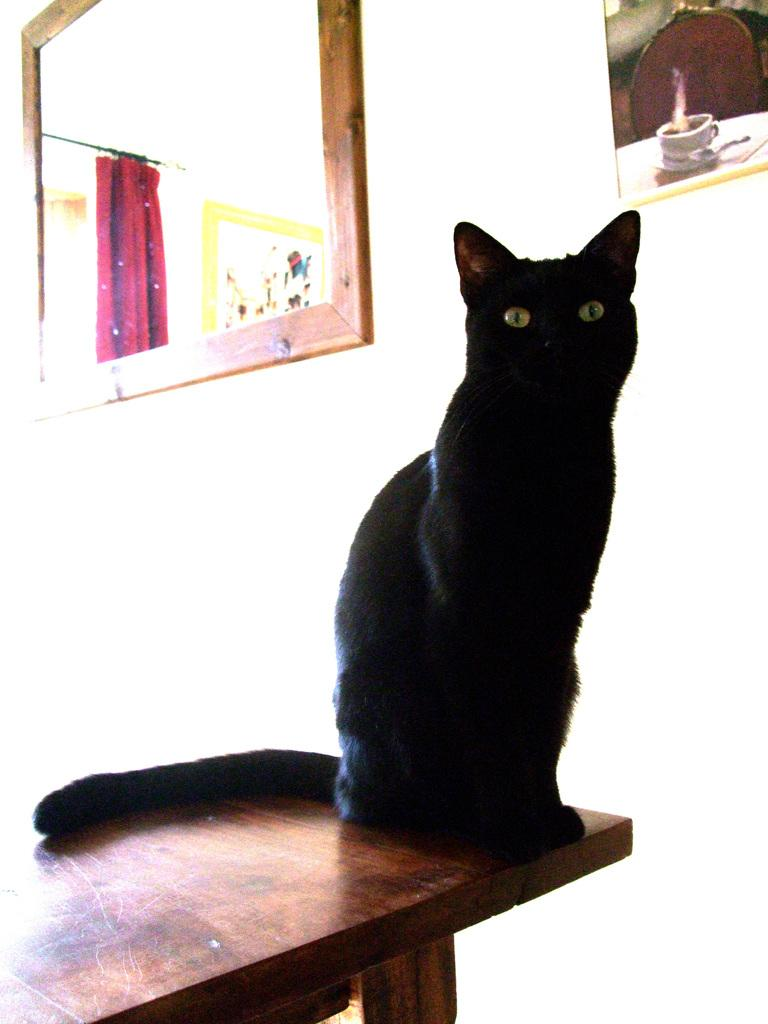What type of animal is in the image? There is a black cat in the image. Where is the cat located in the image? The cat is sitting on a table. Can you describe the cat's position on the table? The cat is positioned on a corner of the table. What is the value of the circle in the image? There is no circle present in the image, so it is not possible to determine its value. 